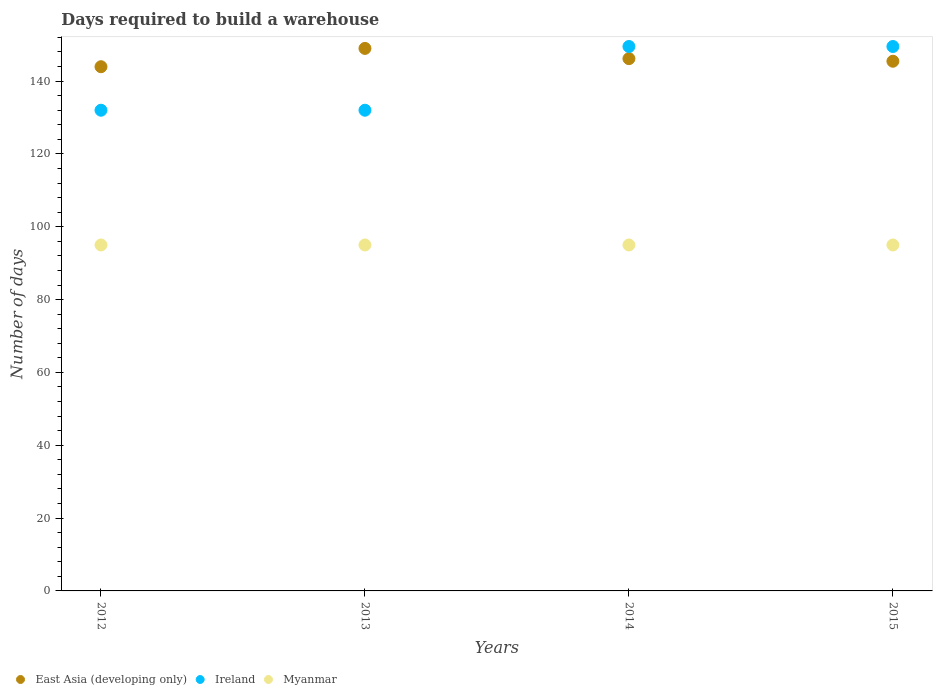How many different coloured dotlines are there?
Provide a short and direct response. 3. What is the days required to build a warehouse in in Ireland in 2012?
Ensure brevity in your answer.  132. Across all years, what is the maximum days required to build a warehouse in in Myanmar?
Your response must be concise. 95. In which year was the days required to build a warehouse in in Myanmar maximum?
Keep it short and to the point. 2012. What is the total days required to build a warehouse in in Myanmar in the graph?
Keep it short and to the point. 380. What is the difference between the days required to build a warehouse in in Myanmar in 2014 and the days required to build a warehouse in in Ireland in 2012?
Offer a terse response. -37. What is the average days required to build a warehouse in in East Asia (developing only) per year?
Provide a short and direct response. 146.14. In the year 2012, what is the difference between the days required to build a warehouse in in East Asia (developing only) and days required to build a warehouse in in Myanmar?
Your answer should be very brief. 48.95. What is the ratio of the days required to build a warehouse in in East Asia (developing only) in 2012 to that in 2015?
Your response must be concise. 0.99. What is the difference between the highest and the second highest days required to build a warehouse in in Ireland?
Offer a terse response. 0. What is the difference between the highest and the lowest days required to build a warehouse in in East Asia (developing only)?
Your answer should be very brief. 5.03. In how many years, is the days required to build a warehouse in in East Asia (developing only) greater than the average days required to build a warehouse in in East Asia (developing only) taken over all years?
Provide a short and direct response. 2. Is the sum of the days required to build a warehouse in in Ireland in 2012 and 2014 greater than the maximum days required to build a warehouse in in East Asia (developing only) across all years?
Your answer should be compact. Yes. Is it the case that in every year, the sum of the days required to build a warehouse in in Ireland and days required to build a warehouse in in Myanmar  is greater than the days required to build a warehouse in in East Asia (developing only)?
Your answer should be compact. Yes. Is the days required to build a warehouse in in Ireland strictly less than the days required to build a warehouse in in Myanmar over the years?
Offer a very short reply. No. How many dotlines are there?
Ensure brevity in your answer.  3. What is the difference between two consecutive major ticks on the Y-axis?
Make the answer very short. 20. Are the values on the major ticks of Y-axis written in scientific E-notation?
Your response must be concise. No. How are the legend labels stacked?
Provide a succinct answer. Horizontal. What is the title of the graph?
Provide a succinct answer. Days required to build a warehouse. Does "Bahamas" appear as one of the legend labels in the graph?
Keep it short and to the point. No. What is the label or title of the X-axis?
Keep it short and to the point. Years. What is the label or title of the Y-axis?
Your answer should be very brief. Number of days. What is the Number of days of East Asia (developing only) in 2012?
Keep it short and to the point. 143.95. What is the Number of days in Ireland in 2012?
Ensure brevity in your answer.  132. What is the Number of days of East Asia (developing only) in 2013?
Your answer should be compact. 148.98. What is the Number of days in Ireland in 2013?
Your response must be concise. 132. What is the Number of days of East Asia (developing only) in 2014?
Provide a short and direct response. 146.17. What is the Number of days of Ireland in 2014?
Your answer should be very brief. 149.5. What is the Number of days in Myanmar in 2014?
Offer a very short reply. 95. What is the Number of days of East Asia (developing only) in 2015?
Provide a short and direct response. 145.45. What is the Number of days in Ireland in 2015?
Provide a succinct answer. 149.5. What is the Number of days in Myanmar in 2015?
Offer a terse response. 95. Across all years, what is the maximum Number of days of East Asia (developing only)?
Provide a short and direct response. 148.98. Across all years, what is the maximum Number of days in Ireland?
Your response must be concise. 149.5. Across all years, what is the minimum Number of days in East Asia (developing only)?
Your response must be concise. 143.95. Across all years, what is the minimum Number of days of Ireland?
Keep it short and to the point. 132. What is the total Number of days in East Asia (developing only) in the graph?
Your response must be concise. 584.54. What is the total Number of days in Ireland in the graph?
Ensure brevity in your answer.  563. What is the total Number of days of Myanmar in the graph?
Ensure brevity in your answer.  380. What is the difference between the Number of days in East Asia (developing only) in 2012 and that in 2013?
Provide a succinct answer. -5.03. What is the difference between the Number of days of Myanmar in 2012 and that in 2013?
Your response must be concise. 0. What is the difference between the Number of days of East Asia (developing only) in 2012 and that in 2014?
Make the answer very short. -2.22. What is the difference between the Number of days in Ireland in 2012 and that in 2014?
Offer a terse response. -17.5. What is the difference between the Number of days in East Asia (developing only) in 2012 and that in 2015?
Your answer should be very brief. -1.5. What is the difference between the Number of days of Ireland in 2012 and that in 2015?
Your answer should be compact. -17.5. What is the difference between the Number of days in Myanmar in 2012 and that in 2015?
Your answer should be very brief. 0. What is the difference between the Number of days of East Asia (developing only) in 2013 and that in 2014?
Keep it short and to the point. 2.81. What is the difference between the Number of days of Ireland in 2013 and that in 2014?
Offer a terse response. -17.5. What is the difference between the Number of days of Myanmar in 2013 and that in 2014?
Give a very brief answer. 0. What is the difference between the Number of days in East Asia (developing only) in 2013 and that in 2015?
Your answer should be very brief. 3.52. What is the difference between the Number of days in Ireland in 2013 and that in 2015?
Make the answer very short. -17.5. What is the difference between the Number of days of Myanmar in 2013 and that in 2015?
Your answer should be compact. 0. What is the difference between the Number of days of East Asia (developing only) in 2012 and the Number of days of Ireland in 2013?
Keep it short and to the point. 11.95. What is the difference between the Number of days in East Asia (developing only) in 2012 and the Number of days in Myanmar in 2013?
Provide a short and direct response. 48.95. What is the difference between the Number of days of Ireland in 2012 and the Number of days of Myanmar in 2013?
Your answer should be compact. 37. What is the difference between the Number of days in East Asia (developing only) in 2012 and the Number of days in Ireland in 2014?
Provide a short and direct response. -5.55. What is the difference between the Number of days of East Asia (developing only) in 2012 and the Number of days of Myanmar in 2014?
Offer a terse response. 48.95. What is the difference between the Number of days in East Asia (developing only) in 2012 and the Number of days in Ireland in 2015?
Your answer should be compact. -5.55. What is the difference between the Number of days of East Asia (developing only) in 2012 and the Number of days of Myanmar in 2015?
Your answer should be compact. 48.95. What is the difference between the Number of days of Ireland in 2012 and the Number of days of Myanmar in 2015?
Keep it short and to the point. 37. What is the difference between the Number of days in East Asia (developing only) in 2013 and the Number of days in Ireland in 2014?
Give a very brief answer. -0.52. What is the difference between the Number of days of East Asia (developing only) in 2013 and the Number of days of Myanmar in 2014?
Provide a succinct answer. 53.98. What is the difference between the Number of days of East Asia (developing only) in 2013 and the Number of days of Ireland in 2015?
Your response must be concise. -0.52. What is the difference between the Number of days of East Asia (developing only) in 2013 and the Number of days of Myanmar in 2015?
Provide a short and direct response. 53.98. What is the difference between the Number of days of East Asia (developing only) in 2014 and the Number of days of Ireland in 2015?
Provide a succinct answer. -3.33. What is the difference between the Number of days in East Asia (developing only) in 2014 and the Number of days in Myanmar in 2015?
Offer a terse response. 51.17. What is the difference between the Number of days in Ireland in 2014 and the Number of days in Myanmar in 2015?
Give a very brief answer. 54.5. What is the average Number of days of East Asia (developing only) per year?
Make the answer very short. 146.14. What is the average Number of days in Ireland per year?
Your response must be concise. 140.75. What is the average Number of days in Myanmar per year?
Ensure brevity in your answer.  95. In the year 2012, what is the difference between the Number of days in East Asia (developing only) and Number of days in Ireland?
Provide a succinct answer. 11.95. In the year 2012, what is the difference between the Number of days of East Asia (developing only) and Number of days of Myanmar?
Keep it short and to the point. 48.95. In the year 2013, what is the difference between the Number of days of East Asia (developing only) and Number of days of Ireland?
Make the answer very short. 16.98. In the year 2013, what is the difference between the Number of days of East Asia (developing only) and Number of days of Myanmar?
Give a very brief answer. 53.98. In the year 2013, what is the difference between the Number of days in Ireland and Number of days in Myanmar?
Keep it short and to the point. 37. In the year 2014, what is the difference between the Number of days of East Asia (developing only) and Number of days of Ireland?
Your answer should be compact. -3.33. In the year 2014, what is the difference between the Number of days of East Asia (developing only) and Number of days of Myanmar?
Ensure brevity in your answer.  51.17. In the year 2014, what is the difference between the Number of days of Ireland and Number of days of Myanmar?
Your response must be concise. 54.5. In the year 2015, what is the difference between the Number of days in East Asia (developing only) and Number of days in Ireland?
Give a very brief answer. -4.05. In the year 2015, what is the difference between the Number of days of East Asia (developing only) and Number of days of Myanmar?
Your answer should be compact. 50.45. In the year 2015, what is the difference between the Number of days in Ireland and Number of days in Myanmar?
Give a very brief answer. 54.5. What is the ratio of the Number of days of East Asia (developing only) in 2012 to that in 2013?
Keep it short and to the point. 0.97. What is the ratio of the Number of days of Ireland in 2012 to that in 2013?
Keep it short and to the point. 1. What is the ratio of the Number of days in Myanmar in 2012 to that in 2013?
Your answer should be very brief. 1. What is the ratio of the Number of days of East Asia (developing only) in 2012 to that in 2014?
Your answer should be very brief. 0.98. What is the ratio of the Number of days of Ireland in 2012 to that in 2014?
Provide a short and direct response. 0.88. What is the ratio of the Number of days of Myanmar in 2012 to that in 2014?
Your answer should be very brief. 1. What is the ratio of the Number of days in East Asia (developing only) in 2012 to that in 2015?
Make the answer very short. 0.99. What is the ratio of the Number of days of Ireland in 2012 to that in 2015?
Your answer should be compact. 0.88. What is the ratio of the Number of days of East Asia (developing only) in 2013 to that in 2014?
Your response must be concise. 1.02. What is the ratio of the Number of days of Ireland in 2013 to that in 2014?
Offer a very short reply. 0.88. What is the ratio of the Number of days of East Asia (developing only) in 2013 to that in 2015?
Give a very brief answer. 1.02. What is the ratio of the Number of days of Ireland in 2013 to that in 2015?
Make the answer very short. 0.88. What is the ratio of the Number of days of Myanmar in 2013 to that in 2015?
Ensure brevity in your answer.  1. What is the ratio of the Number of days in East Asia (developing only) in 2014 to that in 2015?
Your response must be concise. 1. What is the difference between the highest and the second highest Number of days of East Asia (developing only)?
Offer a very short reply. 2.81. What is the difference between the highest and the second highest Number of days in Ireland?
Provide a short and direct response. 0. What is the difference between the highest and the lowest Number of days of East Asia (developing only)?
Give a very brief answer. 5.03. What is the difference between the highest and the lowest Number of days in Ireland?
Offer a terse response. 17.5. 